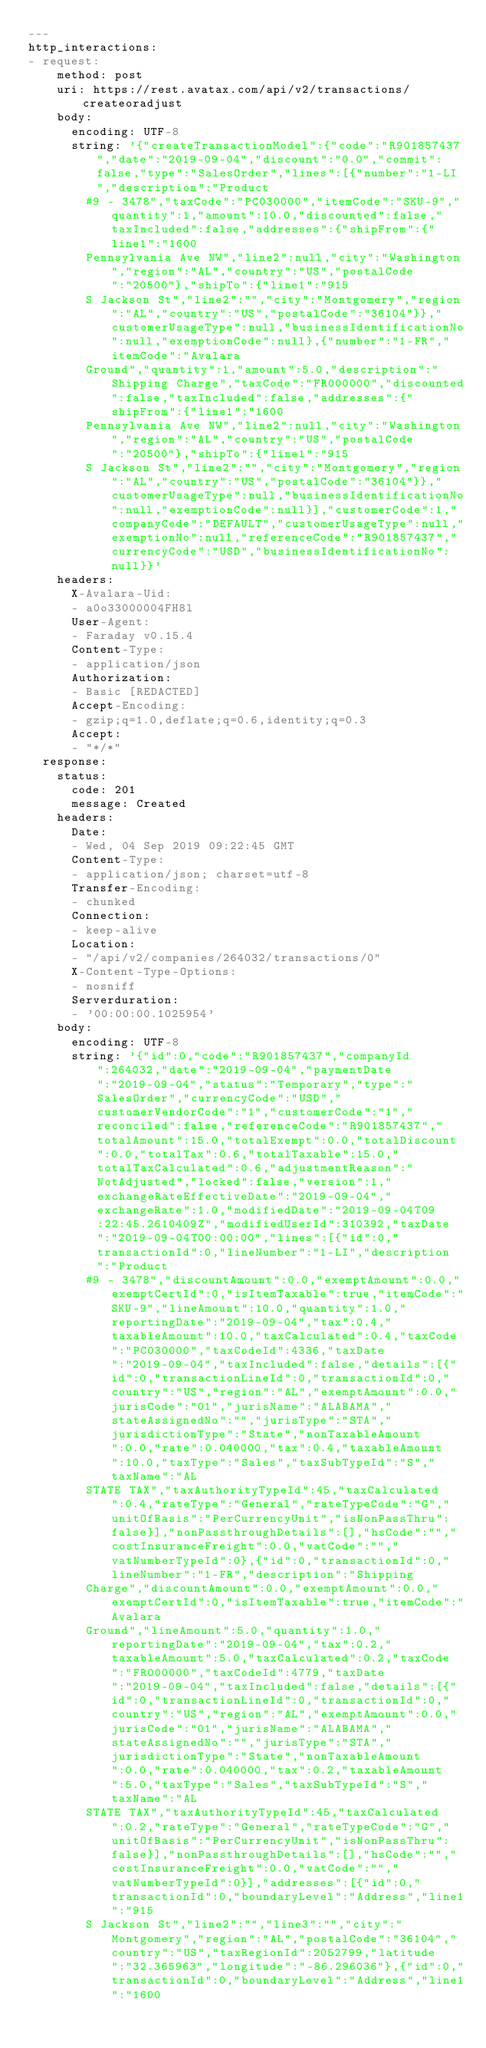Convert code to text. <code><loc_0><loc_0><loc_500><loc_500><_YAML_>---
http_interactions:
- request:
    method: post
    uri: https://rest.avatax.com/api/v2/transactions/createoradjust
    body:
      encoding: UTF-8
      string: '{"createTransactionModel":{"code":"R901857437","date":"2019-09-04","discount":"0.0","commit":false,"type":"SalesOrder","lines":[{"number":"1-LI","description":"Product
        #9 - 3478","taxCode":"PC030000","itemCode":"SKU-9","quantity":1,"amount":10.0,"discounted":false,"taxIncluded":false,"addresses":{"shipFrom":{"line1":"1600
        Pennsylvania Ave NW","line2":null,"city":"Washington","region":"AL","country":"US","postalCode":"20500"},"shipTo":{"line1":"915
        S Jackson St","line2":"","city":"Montgomery","region":"AL","country":"US","postalCode":"36104"}},"customerUsageType":null,"businessIdentificationNo":null,"exemptionCode":null},{"number":"1-FR","itemCode":"Avalara
        Ground","quantity":1,"amount":5.0,"description":"Shipping Charge","taxCode":"FR000000","discounted":false,"taxIncluded":false,"addresses":{"shipFrom":{"line1":"1600
        Pennsylvania Ave NW","line2":null,"city":"Washington","region":"AL","country":"US","postalCode":"20500"},"shipTo":{"line1":"915
        S Jackson St","line2":"","city":"Montgomery","region":"AL","country":"US","postalCode":"36104"}},"customerUsageType":null,"businessIdentificationNo":null,"exemptionCode":null}],"customerCode":1,"companyCode":"DEFAULT","customerUsageType":null,"exemptionNo":null,"referenceCode":"R901857437","currencyCode":"USD","businessIdentificationNo":null}}'
    headers:
      X-Avalara-Uid:
      - a0o33000004FH8l
      User-Agent:
      - Faraday v0.15.4
      Content-Type:
      - application/json
      Authorization:
      - Basic [REDACTED]
      Accept-Encoding:
      - gzip;q=1.0,deflate;q=0.6,identity;q=0.3
      Accept:
      - "*/*"
  response:
    status:
      code: 201
      message: Created
    headers:
      Date:
      - Wed, 04 Sep 2019 09:22:45 GMT
      Content-Type:
      - application/json; charset=utf-8
      Transfer-Encoding:
      - chunked
      Connection:
      - keep-alive
      Location:
      - "/api/v2/companies/264032/transactions/0"
      X-Content-Type-Options:
      - nosniff
      Serverduration:
      - '00:00:00.1025954'
    body:
      encoding: UTF-8
      string: '{"id":0,"code":"R901857437","companyId":264032,"date":"2019-09-04","paymentDate":"2019-09-04","status":"Temporary","type":"SalesOrder","currencyCode":"USD","customerVendorCode":"1","customerCode":"1","reconciled":false,"referenceCode":"R901857437","totalAmount":15.0,"totalExempt":0.0,"totalDiscount":0.0,"totalTax":0.6,"totalTaxable":15.0,"totalTaxCalculated":0.6,"adjustmentReason":"NotAdjusted","locked":false,"version":1,"exchangeRateEffectiveDate":"2019-09-04","exchangeRate":1.0,"modifiedDate":"2019-09-04T09:22:45.2610409Z","modifiedUserId":310392,"taxDate":"2019-09-04T00:00:00","lines":[{"id":0,"transactionId":0,"lineNumber":"1-LI","description":"Product
        #9 - 3478","discountAmount":0.0,"exemptAmount":0.0,"exemptCertId":0,"isItemTaxable":true,"itemCode":"SKU-9","lineAmount":10.0,"quantity":1.0,"reportingDate":"2019-09-04","tax":0.4,"taxableAmount":10.0,"taxCalculated":0.4,"taxCode":"PC030000","taxCodeId":4336,"taxDate":"2019-09-04","taxIncluded":false,"details":[{"id":0,"transactionLineId":0,"transactionId":0,"country":"US","region":"AL","exemptAmount":0.0,"jurisCode":"01","jurisName":"ALABAMA","stateAssignedNo":"","jurisType":"STA","jurisdictionType":"State","nonTaxableAmount":0.0,"rate":0.040000,"tax":0.4,"taxableAmount":10.0,"taxType":"Sales","taxSubTypeId":"S","taxName":"AL
        STATE TAX","taxAuthorityTypeId":45,"taxCalculated":0.4,"rateType":"General","rateTypeCode":"G","unitOfBasis":"PerCurrencyUnit","isNonPassThru":false}],"nonPassthroughDetails":[],"hsCode":"","costInsuranceFreight":0.0,"vatCode":"","vatNumberTypeId":0},{"id":0,"transactionId":0,"lineNumber":"1-FR","description":"Shipping
        Charge","discountAmount":0.0,"exemptAmount":0.0,"exemptCertId":0,"isItemTaxable":true,"itemCode":"Avalara
        Ground","lineAmount":5.0,"quantity":1.0,"reportingDate":"2019-09-04","tax":0.2,"taxableAmount":5.0,"taxCalculated":0.2,"taxCode":"FR000000","taxCodeId":4779,"taxDate":"2019-09-04","taxIncluded":false,"details":[{"id":0,"transactionLineId":0,"transactionId":0,"country":"US","region":"AL","exemptAmount":0.0,"jurisCode":"01","jurisName":"ALABAMA","stateAssignedNo":"","jurisType":"STA","jurisdictionType":"State","nonTaxableAmount":0.0,"rate":0.040000,"tax":0.2,"taxableAmount":5.0,"taxType":"Sales","taxSubTypeId":"S","taxName":"AL
        STATE TAX","taxAuthorityTypeId":45,"taxCalculated":0.2,"rateType":"General","rateTypeCode":"G","unitOfBasis":"PerCurrencyUnit","isNonPassThru":false}],"nonPassthroughDetails":[],"hsCode":"","costInsuranceFreight":0.0,"vatCode":"","vatNumberTypeId":0}],"addresses":[{"id":0,"transactionId":0,"boundaryLevel":"Address","line1":"915
        S Jackson St","line2":"","line3":"","city":"Montgomery","region":"AL","postalCode":"36104","country":"US","taxRegionId":2052799,"latitude":"32.365963","longitude":"-86.296036"},{"id":0,"transactionId":0,"boundaryLevel":"Address","line1":"1600</code> 